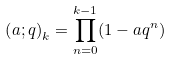<formula> <loc_0><loc_0><loc_500><loc_500>\left ( a ; q \right ) _ { k } = \prod ^ { k - 1 } _ { n = 0 } ( 1 - a q ^ { n } )</formula> 